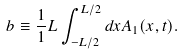Convert formula to latex. <formula><loc_0><loc_0><loc_500><loc_500>b \equiv \frac { 1 } { 1 } L \int _ { - L / 2 } ^ { L / 2 } d x A _ { 1 } ( x , t ) .</formula> 